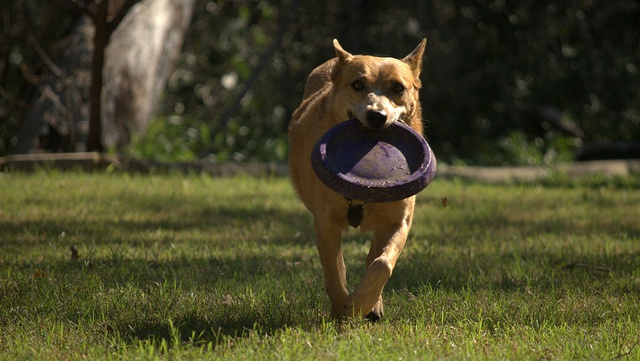Describe the objects in this image and their specific colors. I can see dog in black, maroon, and gray tones and frisbee in black, gray, and darkgray tones in this image. 